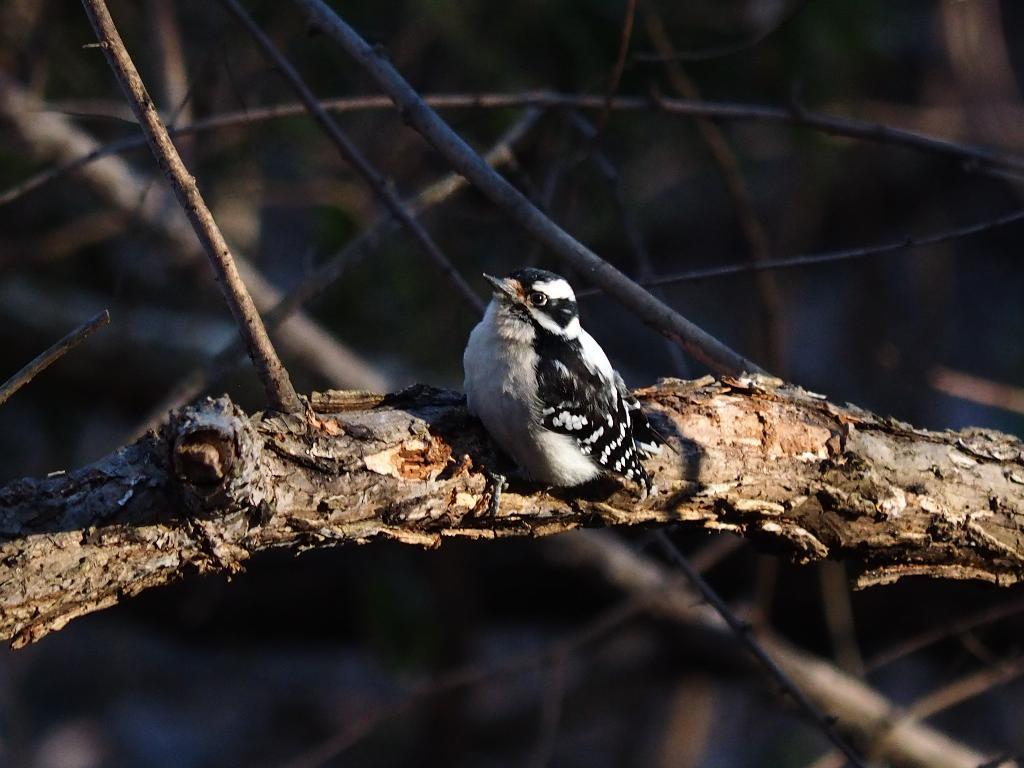What is the main subject of the image? There is a bird on a wooden surface in the image. What other objects can be seen in the image? There are wooden sticks visible in the image. Can you describe the background of the image? The background of the image is blurry. What type of plant is growing in the frame of the image? There is no frame or plant present in the image; it features a bird on a wooden surface and wooden sticks. 